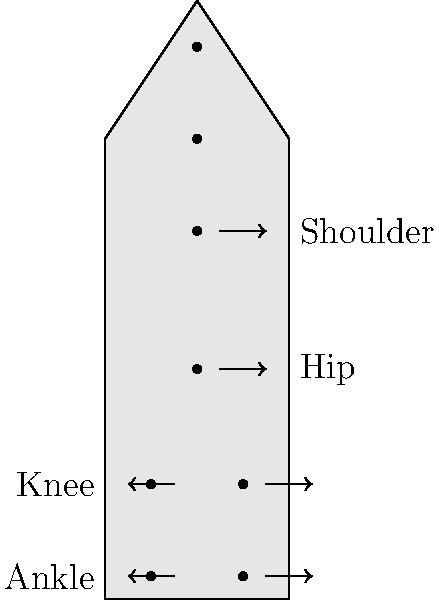During a long march, soldiers experience various forces acting on their joints. Based on the diagram, which joints are likely to experience the highest compressive forces, and why would this information be crucial for a high-ranking officer to consider when planning extended operations? To answer this question, we need to consider the biomechanics of a soldier's body during a long march:

1. Force distribution: The weight of the body and equipment is distributed downward through the skeletal system.

2. Joint analysis:
   a. Shoulder: Experiences tension from carrying equipment but less compressive force.
   b. Hip: Bears the weight of the upper body and equipment.
   c. Knee: Supports the entire body weight plus equipment during each step.
   d. Ankle: Also bears the full body weight and equipment, with added stress from impact.

3. Compressive force calculation: 
   Let $F_c$ be the compressive force, $m$ the mass (body + equipment), and $g$ the acceleration due to gravity.
   $$F_c = m * g$$

4. Impact force: During marching, impact forces can be 2-3 times body weight.
   $$F_i = (2 \text{ to } 3) * m * g$$

5. Joints experiencing highest compressive forces: Knees and ankles, due to bearing the full weight and impact forces.

6. Strategic importance:
   a. Injury prevention: Understanding these forces helps in developing training and equipment to reduce joint stress.
   b. Operation planning: Allows for better estimation of march durations and rest periods.
   c. Medical preparedness: Helps in anticipating potential injuries and required medical support.
   d. Equipment design: Informs the development of load-bearing equipment and footwear.

Understanding these biomechanical factors enables a high-ranking officer to make informed decisions about troop movement, equipment, and overall strategy in extended operations.
Answer: Knees and ankles; crucial for injury prevention, operation planning, medical preparedness, and equipment design. 